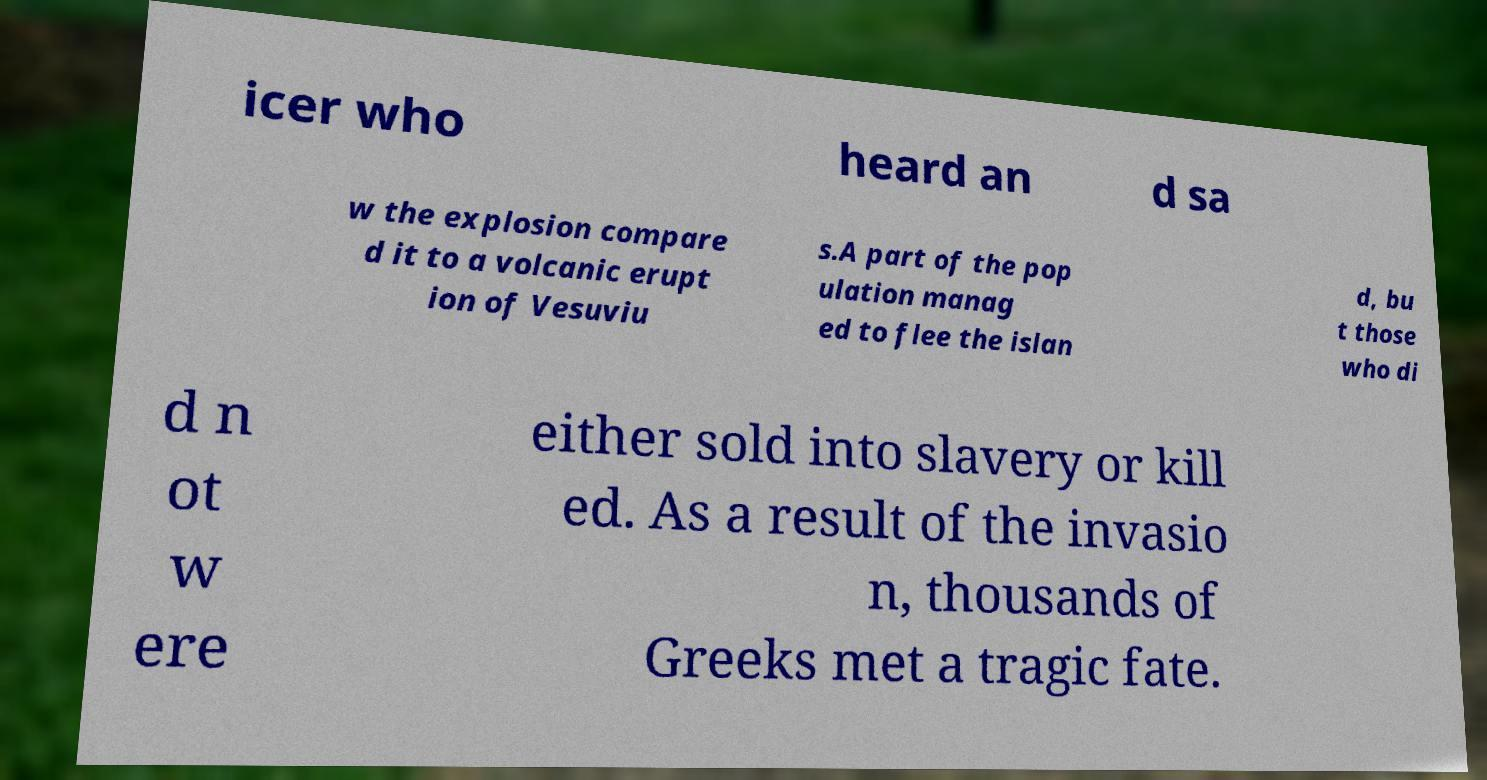For documentation purposes, I need the text within this image transcribed. Could you provide that? icer who heard an d sa w the explosion compare d it to a volcanic erupt ion of Vesuviu s.A part of the pop ulation manag ed to flee the islan d, bu t those who di d n ot w ere either sold into slavery or kill ed. As a result of the invasio n, thousands of Greeks met a tragic fate. 